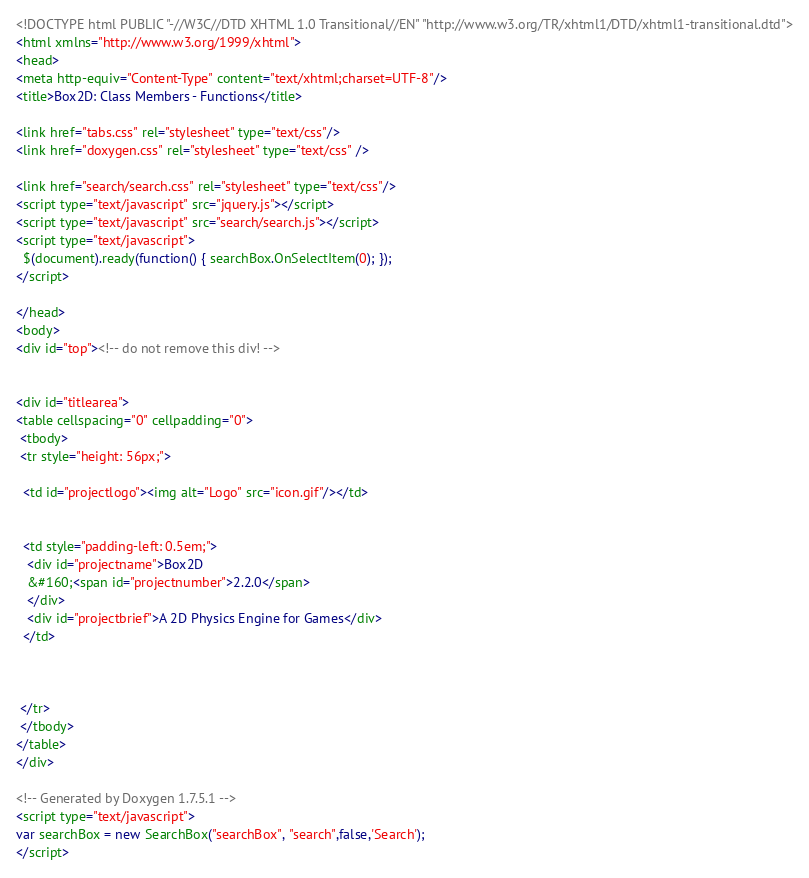Convert code to text. <code><loc_0><loc_0><loc_500><loc_500><_HTML_><!DOCTYPE html PUBLIC "-//W3C//DTD XHTML 1.0 Transitional//EN" "http://www.w3.org/TR/xhtml1/DTD/xhtml1-transitional.dtd">
<html xmlns="http://www.w3.org/1999/xhtml">
<head>
<meta http-equiv="Content-Type" content="text/xhtml;charset=UTF-8"/>
<title>Box2D: Class Members - Functions</title>

<link href="tabs.css" rel="stylesheet" type="text/css"/>
<link href="doxygen.css" rel="stylesheet" type="text/css" />

<link href="search/search.css" rel="stylesheet" type="text/css"/>
<script type="text/javascript" src="jquery.js"></script>
<script type="text/javascript" src="search/search.js"></script>
<script type="text/javascript">
  $(document).ready(function() { searchBox.OnSelectItem(0); });
</script>

</head>
<body>
<div id="top"><!-- do not remove this div! -->


<div id="titlearea">
<table cellspacing="0" cellpadding="0">
 <tbody>
 <tr style="height: 56px;">
  
  <td id="projectlogo"><img alt="Logo" src="icon.gif"/></td>
  
  
  <td style="padding-left: 0.5em;">
   <div id="projectname">Box2D
   &#160;<span id="projectnumber">2.2.0</span>
   </div>
   <div id="projectbrief">A 2D Physics Engine for Games</div>
  </td>
  
  
  
 </tr>
 </tbody>
</table>
</div>

<!-- Generated by Doxygen 1.7.5.1 -->
<script type="text/javascript">
var searchBox = new SearchBox("searchBox", "search",false,'Search');
</script></code> 